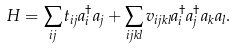<formula> <loc_0><loc_0><loc_500><loc_500>H = \sum _ { i j } t _ { i j } a _ { i } ^ { \dag } a _ { j } + \sum _ { i j k l } v _ { i j k l } a _ { i } ^ { \dag } a _ { j } ^ { \dag } a _ { k } a _ { l } .</formula> 